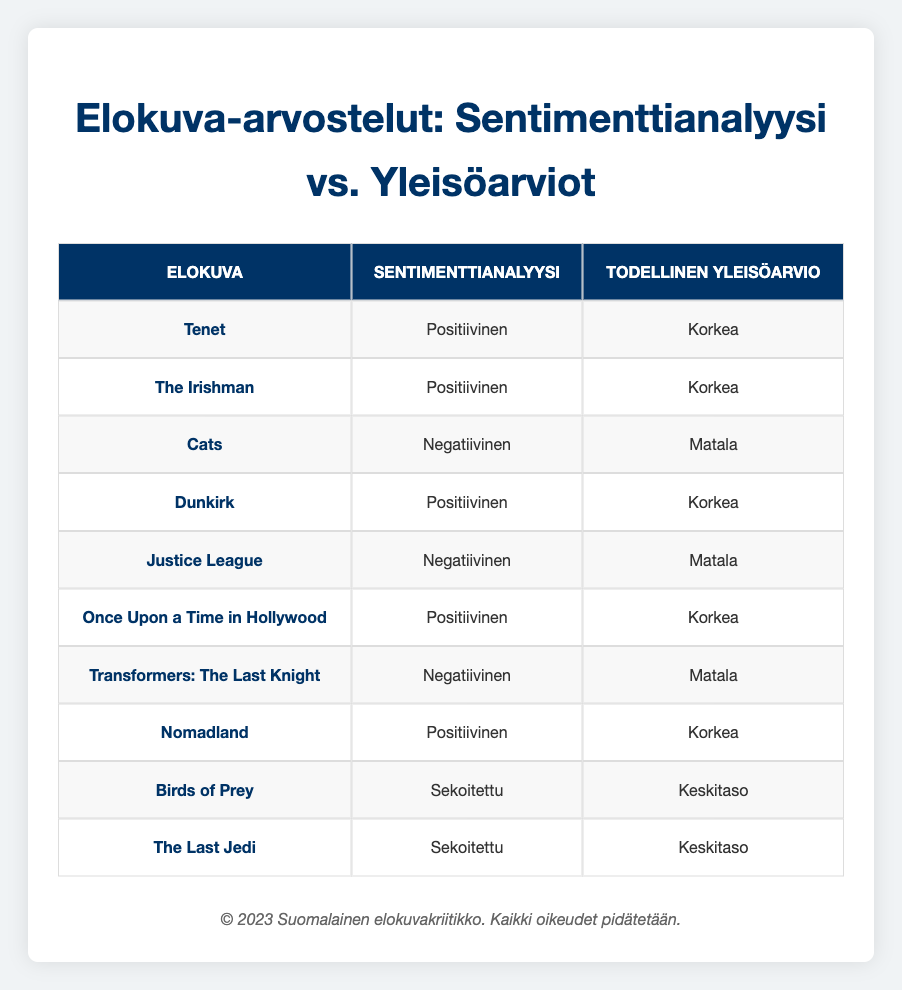What is the sentiment analysis for the movie "Dunkirk"? According to the table, the sentiment analysis for "Dunkirk" is listed as "Positive."
Answer: Positive How many movies have a positive sentiment analysis and a high actual audience rating? The table shows that the movies with a positive sentiment analysis and a high audience rating are "Tenet," "The Irishman," "Dunkirk," "Once Upon a Time in Hollywood," and "Nomadland." There are a total of 5 movies.
Answer: 5 Is "Justice League" associated with a low actual audience rating? The table indicates that "Justice League" indeed has a low actual audience rating.
Answer: Yes Which movies have a negative sentiment analysis? The movies that have a negative sentiment analysis according to the table are "Cats," "Justice League," and "Transformers: The Last Knight."
Answer: Cats, Justice League, Transformers: The Last Knight What is the ratio of movies with a negative sentiment analysis to those with a positive sentiment analysis? There are 3 movies with a negative sentiment analysis ("Cats," "Justice League," and "Transformers: The Last Knight") and 5 movies with a positive sentiment analysis ("Tenet," "The Irishman," "Dunkirk," "Once Upon a Time in Hollywood," and "Nomadland"). The ratio is 3:5.
Answer: 3:5 Among the movies with a mixed sentiment analysis, what are their actual audience ratings? "Birds of Prey" and "The Last Jedi" both have a mixed sentiment analysis, with actual audience ratings of "Medium."
Answer: Medium How many movies in total have either a high or low actual audience rating? Looking through the table, the movies with a high audience rating are 5 ("Tenet," "The Irishman," "Dunkirk," "Once Upon a Time in Hollywood," "Nomadland") and the movies with a low rating are also 3 ("Cats," "Justice League," and "Transformers: The Last Knight"). Adding these up gives a total of 8 movies.
Answer: 8 Is there any movie in the table that has a high audience rating and a mixed sentiment analysis? The table shows that there are no movies that have both a high audience rating and a mixed sentiment analysis.
Answer: No 